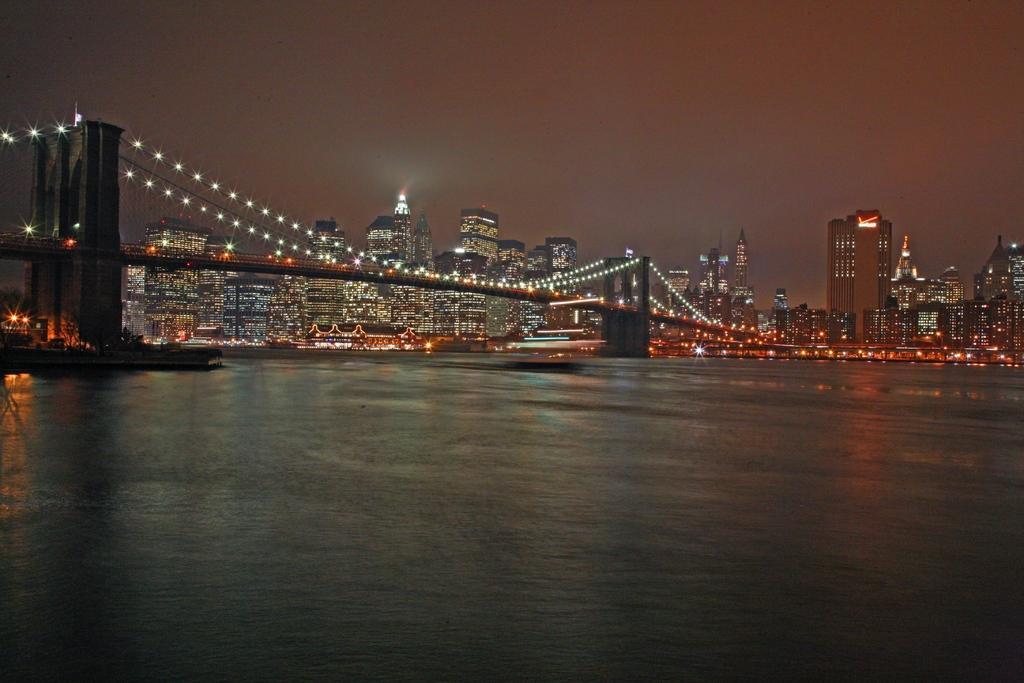Describe this image in one or two sentences. In the foreground of this image, at the bottom, there is water. In the middle, there is a bridge. In the background, there are buildings and the sky. 